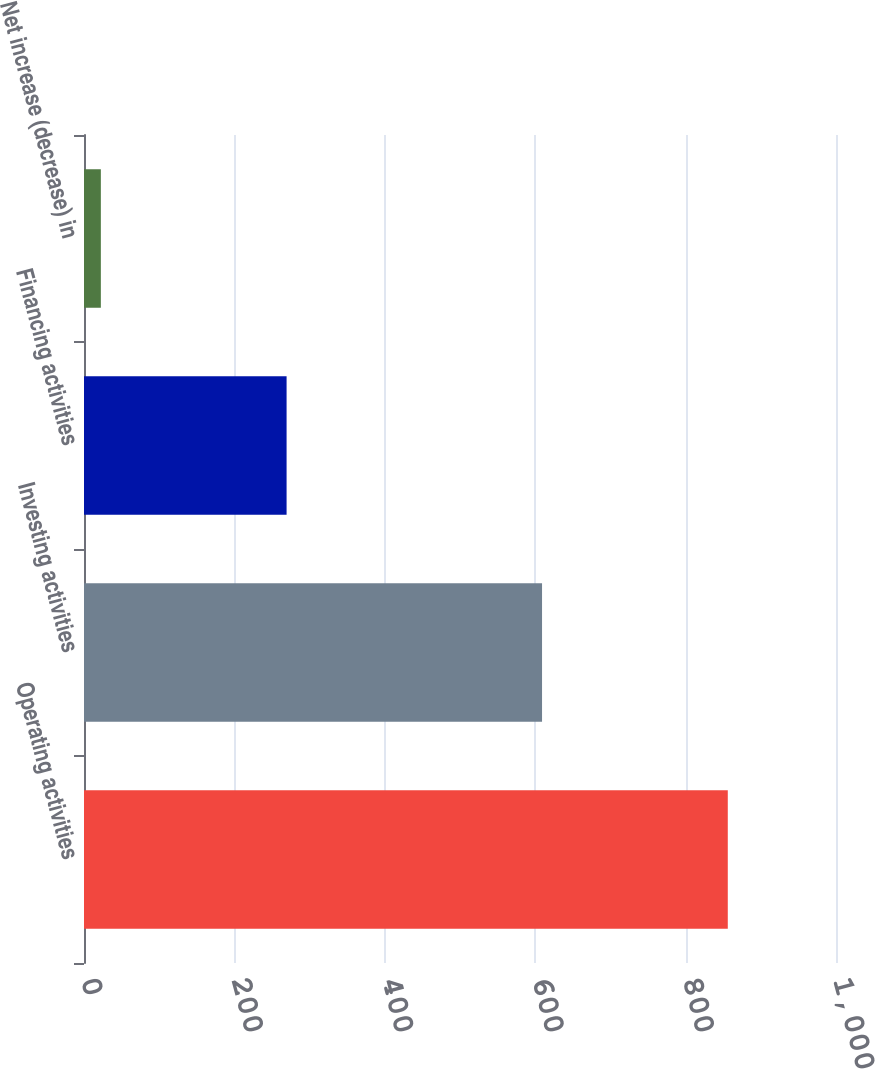Convert chart. <chart><loc_0><loc_0><loc_500><loc_500><bar_chart><fcel>Operating activities<fcel>Investing activities<fcel>Financing activities<fcel>Net increase (decrease) in<nl><fcel>856.1<fcel>609.1<fcel>269.4<fcel>22.4<nl></chart> 